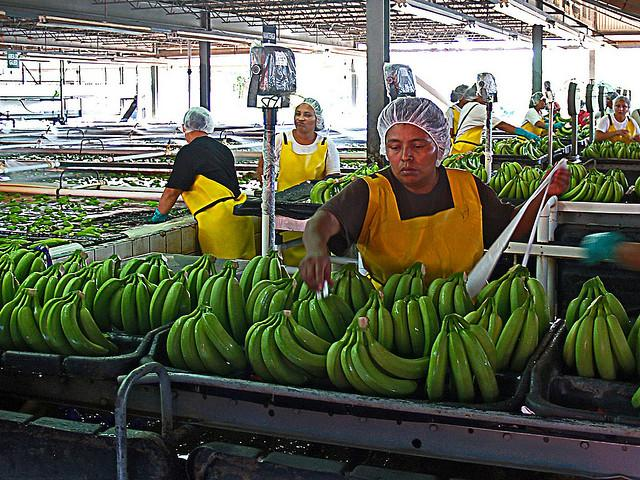What does the hair cap prevent? Please explain your reasoning. stray hairs. The hair cap prevents stray hairs from landing on the fruits. 